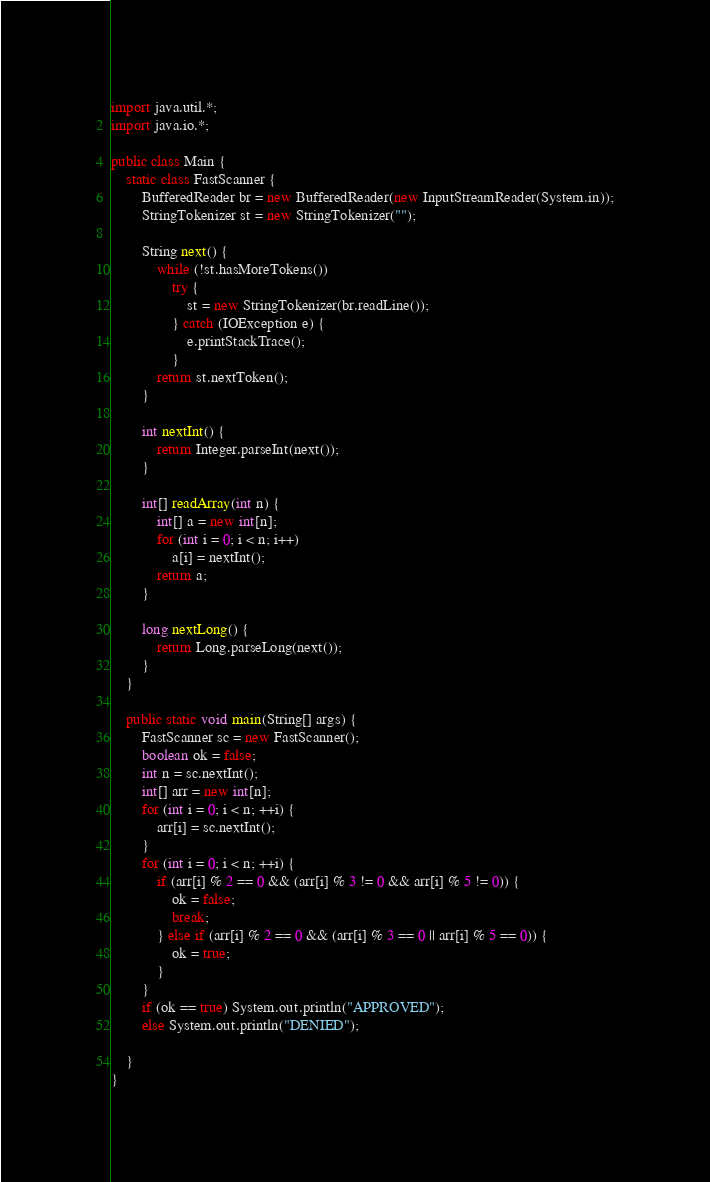Convert code to text. <code><loc_0><loc_0><loc_500><loc_500><_Java_>

import java.util.*;
import java.io.*;

public class Main {
    static class FastScanner {
        BufferedReader br = new BufferedReader(new InputStreamReader(System.in));
        StringTokenizer st = new StringTokenizer("");

        String next() {
            while (!st.hasMoreTokens())
                try {
                    st = new StringTokenizer(br.readLine());
                } catch (IOException e) {
                    e.printStackTrace();
                }
            return st.nextToken();
        }

        int nextInt() {
            return Integer.parseInt(next());
        }

        int[] readArray(int n) {
            int[] a = new int[n];
            for (int i = 0; i < n; i++)
                a[i] = nextInt();
            return a;
        }

        long nextLong() {
            return Long.parseLong(next());
        }
    }

    public static void main(String[] args) {
        FastScanner sc = new FastScanner();
        boolean ok = false;
        int n = sc.nextInt();
        int[] arr = new int[n];
        for (int i = 0; i < n; ++i) {
            arr[i] = sc.nextInt();
        }
        for (int i = 0; i < n; ++i) {
            if (arr[i] % 2 == 0 && (arr[i] % 3 != 0 && arr[i] % 5 != 0)) {
                ok = false;
                break;
            } else if (arr[i] % 2 == 0 && (arr[i] % 3 == 0 || arr[i] % 5 == 0)) {
                ok = true;
            }
        }
        if (ok == true) System.out.println("APPROVED");
        else System.out.println("DENIED");

    }
}
</code> 